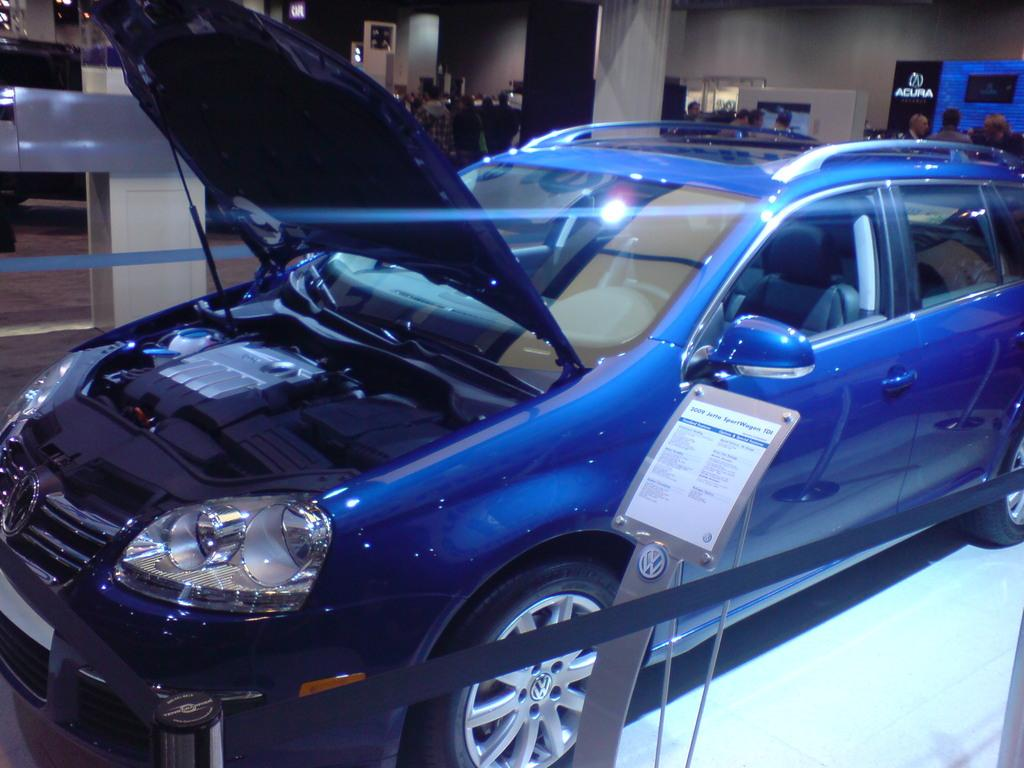What type of vehicle is in the image? There is a blue color car in the image. What structure can be seen with a pole in the image? There is a board with a pole in the image. What are the ropes attached to in the image? The ropes are attached to poles in the image. How many people are visible in the image? There are many people in the back of the image. What architectural feature can be seen in the image? There is a pillar in the image. What type of enclosure is present in the image? There are walls in the image. What type of glue is being used to hold the ship together in the image? There is no ship present in the image, so there is no glue being used to hold it together. What part of the brain can be seen in the image? There is no brain present in the image. 